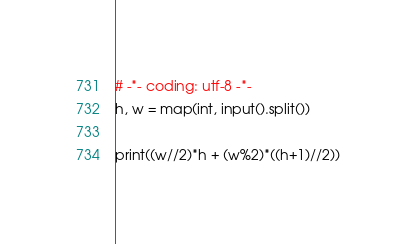<code> <loc_0><loc_0><loc_500><loc_500><_Python_># -*- coding: utf-8 -*-
h, w = map(int, input().split())

print((w//2)*h + (w%2)*((h+1)//2))
</code> 